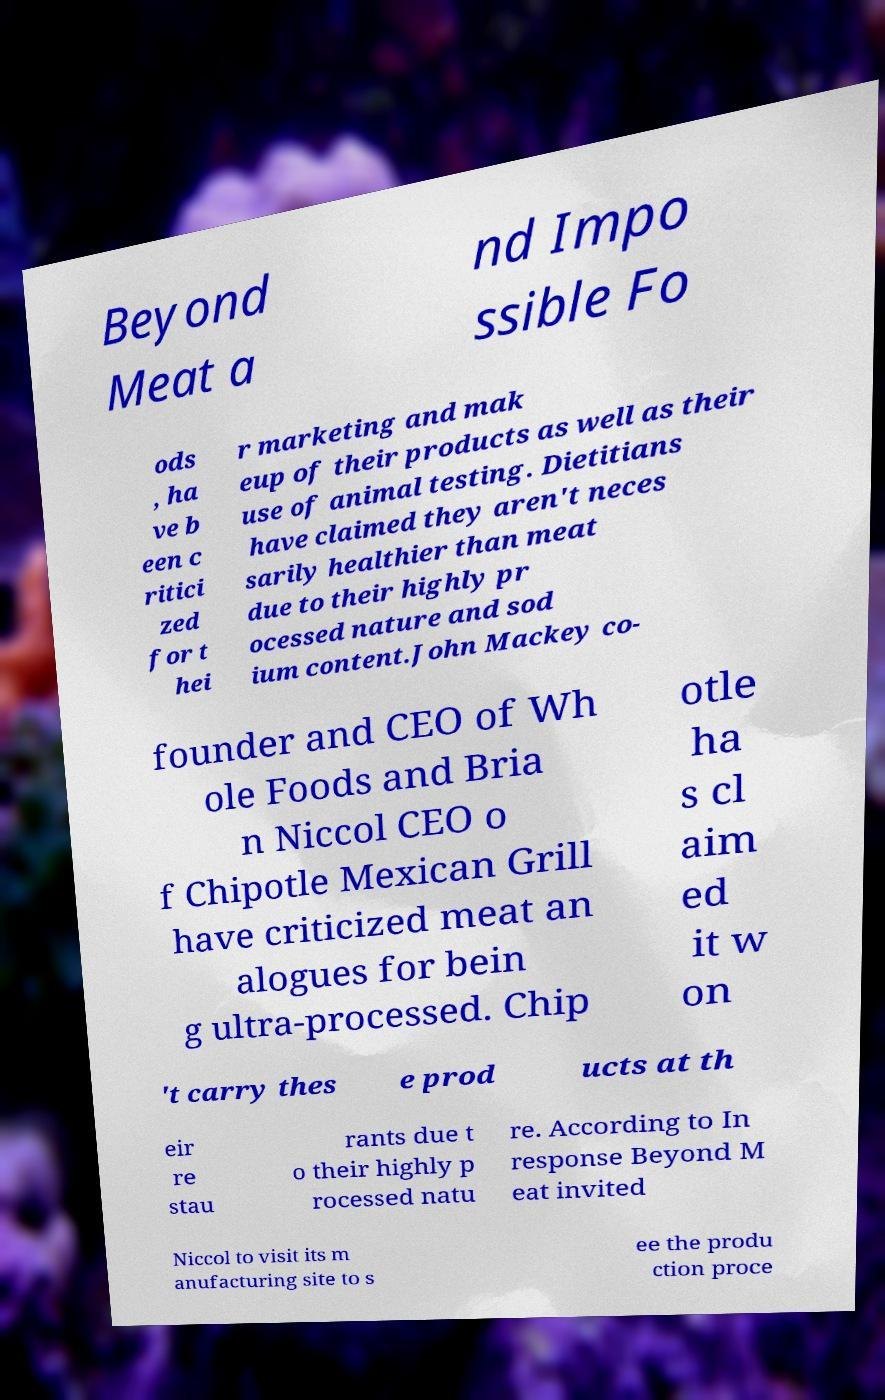Please read and relay the text visible in this image. What does it say? Beyond Meat a nd Impo ssible Fo ods , ha ve b een c ritici zed for t hei r marketing and mak eup of their products as well as their use of animal testing. Dietitians have claimed they aren't neces sarily healthier than meat due to their highly pr ocessed nature and sod ium content.John Mackey co- founder and CEO of Wh ole Foods and Bria n Niccol CEO o f Chipotle Mexican Grill have criticized meat an alogues for bein g ultra-processed. Chip otle ha s cl aim ed it w on 't carry thes e prod ucts at th eir re stau rants due t o their highly p rocessed natu re. According to In response Beyond M eat invited Niccol to visit its m anufacturing site to s ee the produ ction proce 